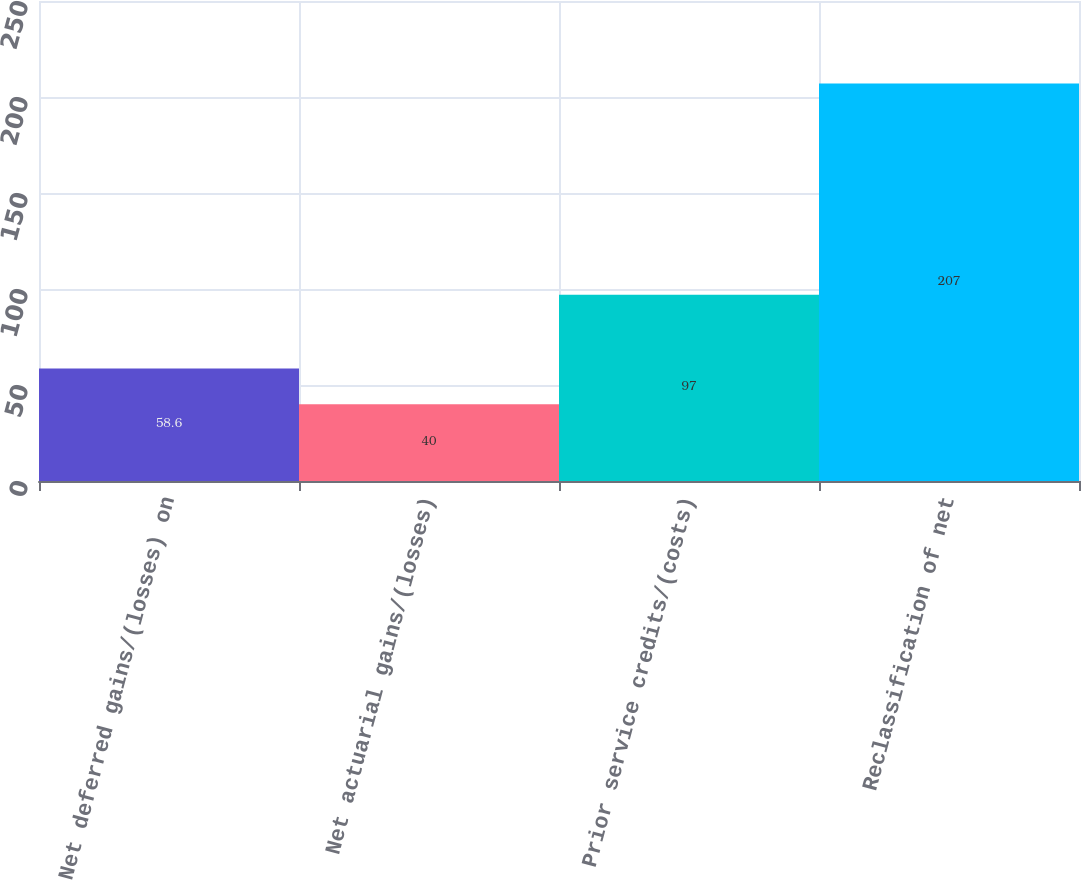Convert chart to OTSL. <chart><loc_0><loc_0><loc_500><loc_500><bar_chart><fcel>Net deferred gains/(losses) on<fcel>Net actuarial gains/(losses)<fcel>Prior service credits/(costs)<fcel>Reclassification of net<nl><fcel>58.6<fcel>40<fcel>97<fcel>207<nl></chart> 